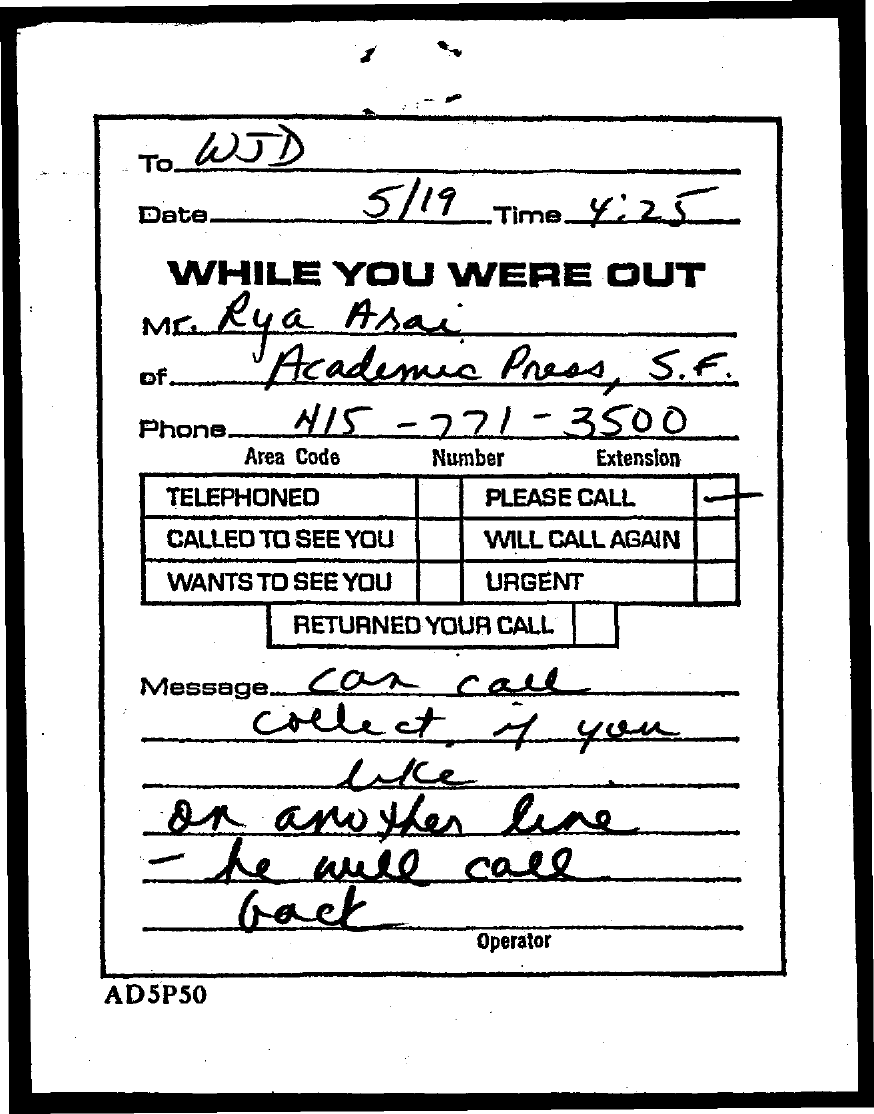Point out several critical features in this image. The time mentioned in the document is 4:25. The telephone number of Mr. Rya Arai is 415-771-3500. The date mentioned in this document is 5/19. The message is addressed to the person known as WJD. 